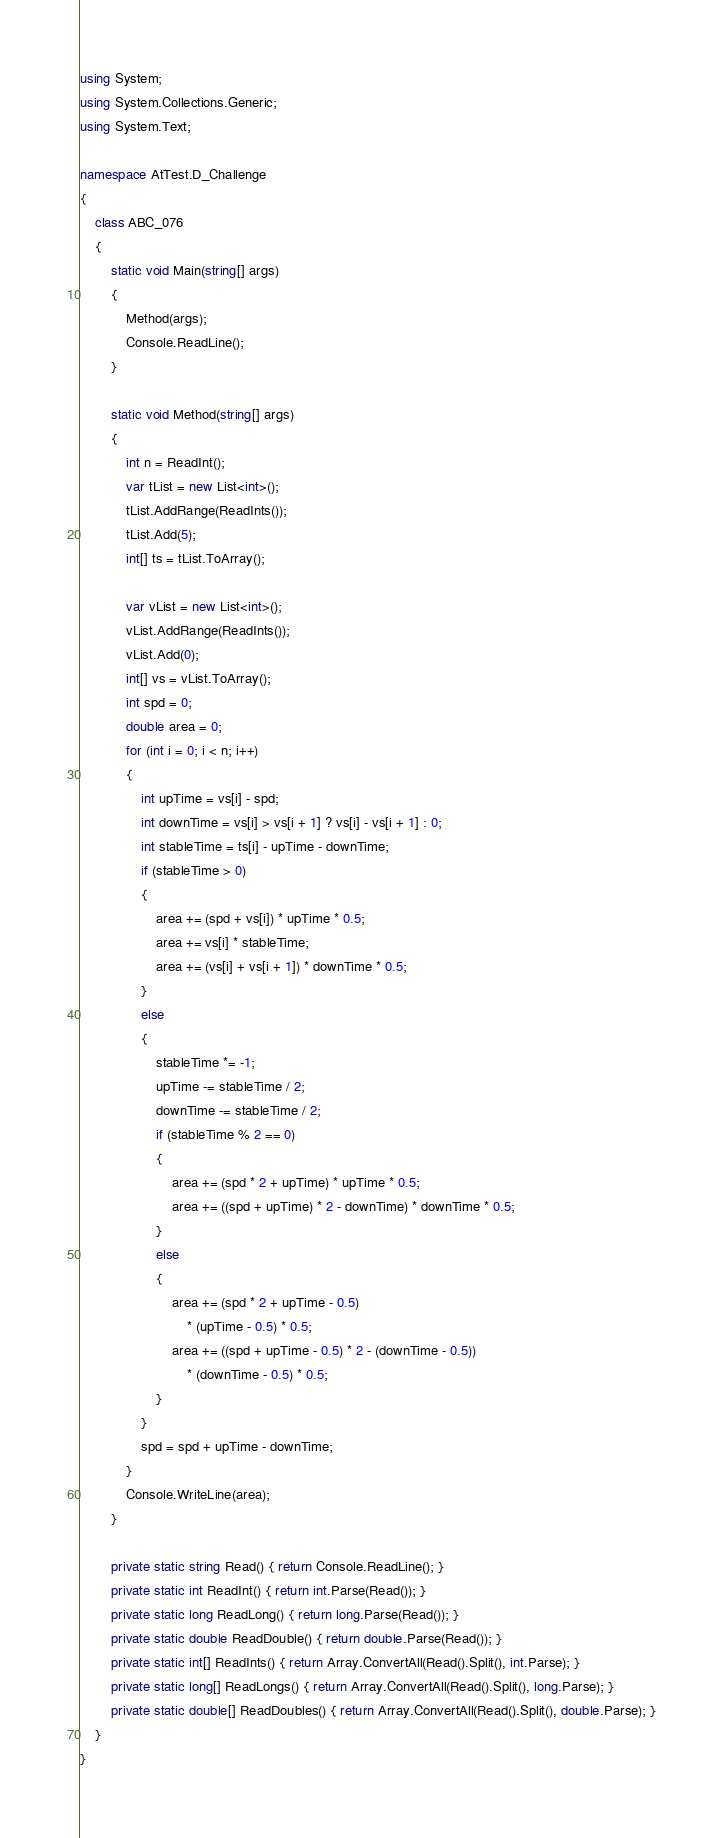<code> <loc_0><loc_0><loc_500><loc_500><_C#_>using System;
using System.Collections.Generic;
using System.Text;

namespace AtTest.D_Challenge
{
    class ABC_076
    {
        static void Main(string[] args)
        {
            Method(args);
            Console.ReadLine();
        }

        static void Method(string[] args)
        {
            int n = ReadInt();
            var tList = new List<int>();
            tList.AddRange(ReadInts());
            tList.Add(5);
            int[] ts = tList.ToArray();

            var vList = new List<int>();
            vList.AddRange(ReadInts());
            vList.Add(0);
            int[] vs = vList.ToArray();
            int spd = 0;
            double area = 0;
            for (int i = 0; i < n; i++)
            {
                int upTime = vs[i] - spd;
                int downTime = vs[i] > vs[i + 1] ? vs[i] - vs[i + 1] : 0;
                int stableTime = ts[i] - upTime - downTime;
                if (stableTime > 0)
                {
                    area += (spd + vs[i]) * upTime * 0.5;
                    area += vs[i] * stableTime;
                    area += (vs[i] + vs[i + 1]) * downTime * 0.5;
                }
                else
                {
                    stableTime *= -1;
                    upTime -= stableTime / 2;
                    downTime -= stableTime / 2;
                    if (stableTime % 2 == 0)
                    {
                        area += (spd * 2 + upTime) * upTime * 0.5;
                        area += ((spd + upTime) * 2 - downTime) * downTime * 0.5;
                    }
                    else
                    {
                        area += (spd * 2 + upTime - 0.5)
                            * (upTime - 0.5) * 0.5;
                        area += ((spd + upTime - 0.5) * 2 - (downTime - 0.5))
                            * (downTime - 0.5) * 0.5;
                    }
                }
                spd = spd + upTime - downTime;
            }
            Console.WriteLine(area);
        }

        private static string Read() { return Console.ReadLine(); }
        private static int ReadInt() { return int.Parse(Read()); }
        private static long ReadLong() { return long.Parse(Read()); }
        private static double ReadDouble() { return double.Parse(Read()); }
        private static int[] ReadInts() { return Array.ConvertAll(Read().Split(), int.Parse); }
        private static long[] ReadLongs() { return Array.ConvertAll(Read().Split(), long.Parse); }
        private static double[] ReadDoubles() { return Array.ConvertAll(Read().Split(), double.Parse); }
    }
}
</code> 